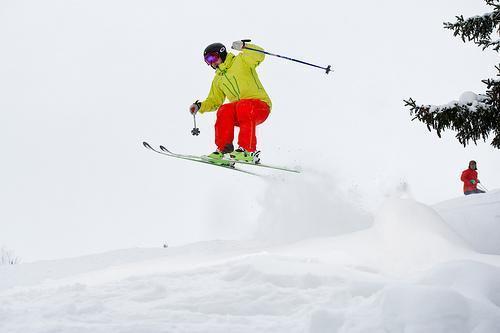How many people are in the photo?
Give a very brief answer. 2. 